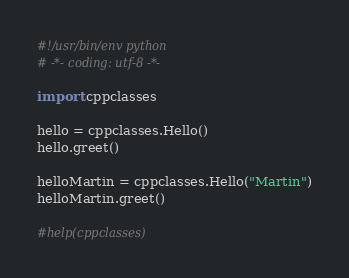<code> <loc_0><loc_0><loc_500><loc_500><_Python_>#!/usr/bin/env python
# -*- coding: utf-8 -*-

import cppclasses

hello = cppclasses.Hello()
hello.greet()

helloMartin = cppclasses.Hello("Martin")
helloMartin.greet()

#help(cppclasses)
</code> 